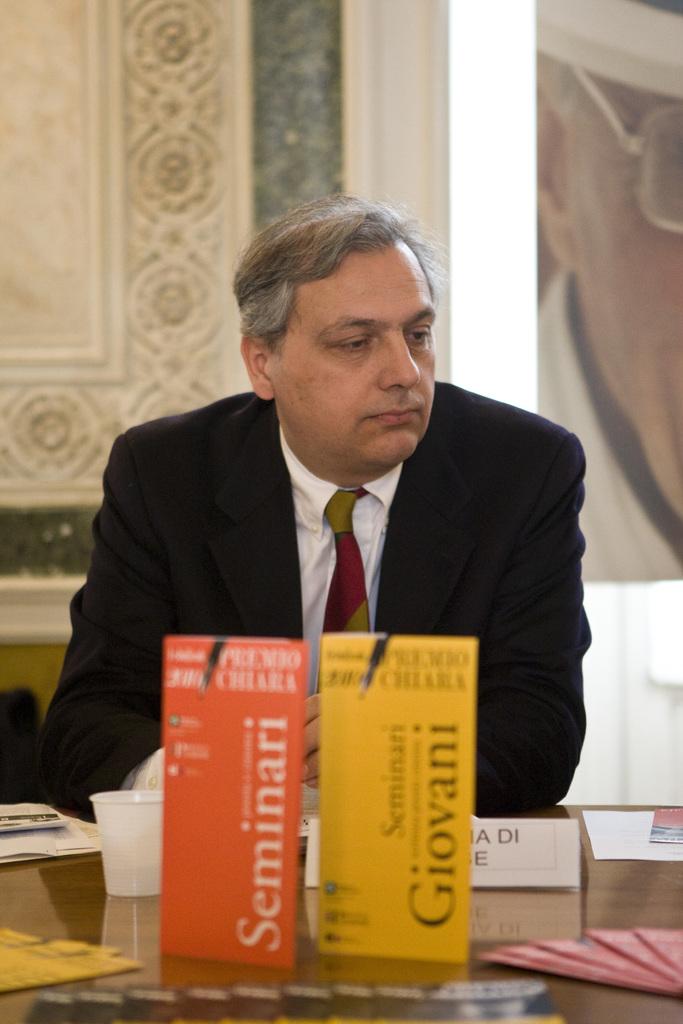What is the main text on the orange card?
Provide a short and direct response. Seminari. 